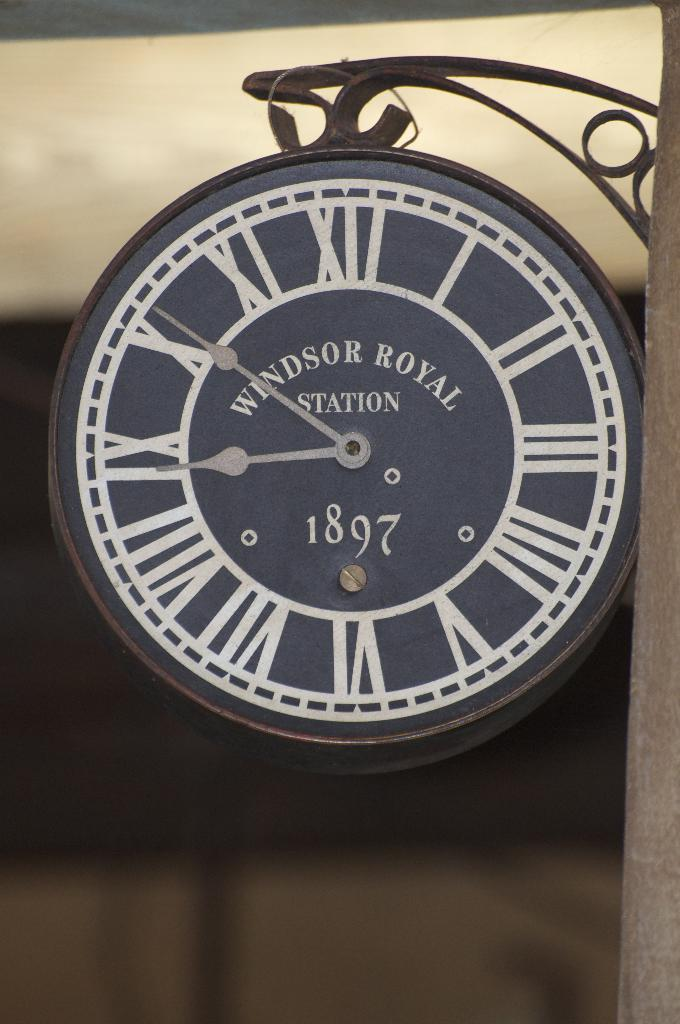<image>
Write a terse but informative summary of the picture. A clock face with Roman numerals and the words Windsor Royal. 